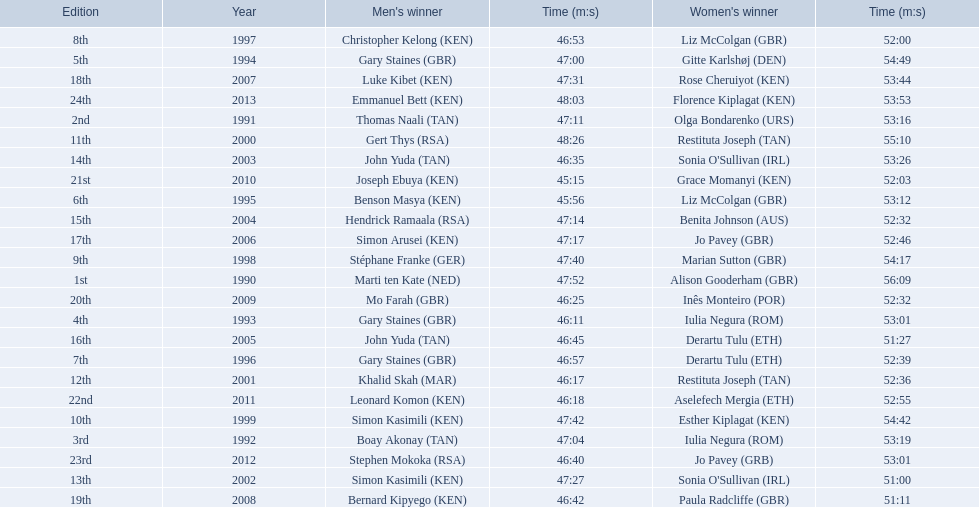Which runners are from kenya? (ken) Benson Masya (KEN), Christopher Kelong (KEN), Simon Kasimili (KEN), Simon Kasimili (KEN), Simon Arusei (KEN), Luke Kibet (KEN), Bernard Kipyego (KEN), Joseph Ebuya (KEN), Leonard Komon (KEN), Emmanuel Bett (KEN). Of these, which times are under 46 minutes? Benson Masya (KEN), Joseph Ebuya (KEN). Which of these runners had the faster time? Joseph Ebuya (KEN). 